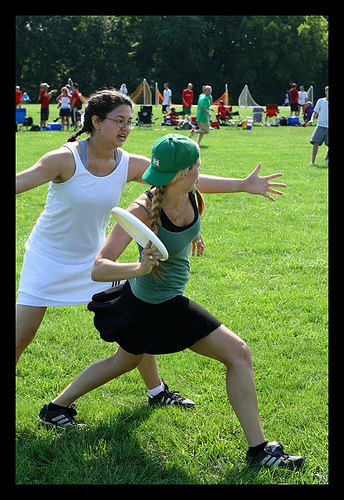Describe the objects in this image and their specific colors. I can see people in black, gray, darkgreen, and teal tones, people in black, lightblue, darkgray, and gray tones, people in black, gray, darkgray, and maroon tones, frisbee in black, darkgray, lightblue, white, and beige tones, and people in black, lightblue, blue, and gray tones in this image. 